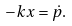Convert formula to latex. <formula><loc_0><loc_0><loc_500><loc_500>- k x = \dot { p } .</formula> 